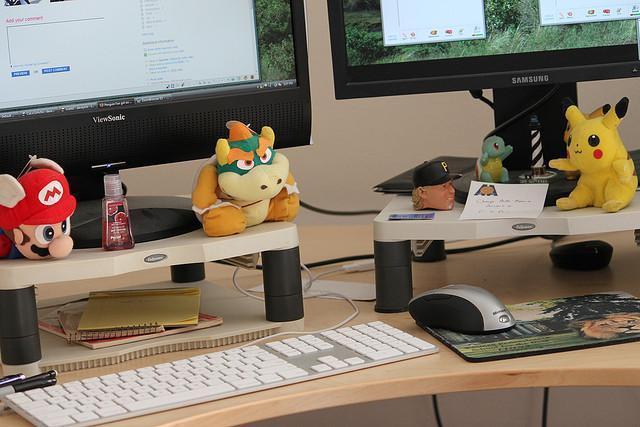How many tvs are visible?
Give a very brief answer. 2. 